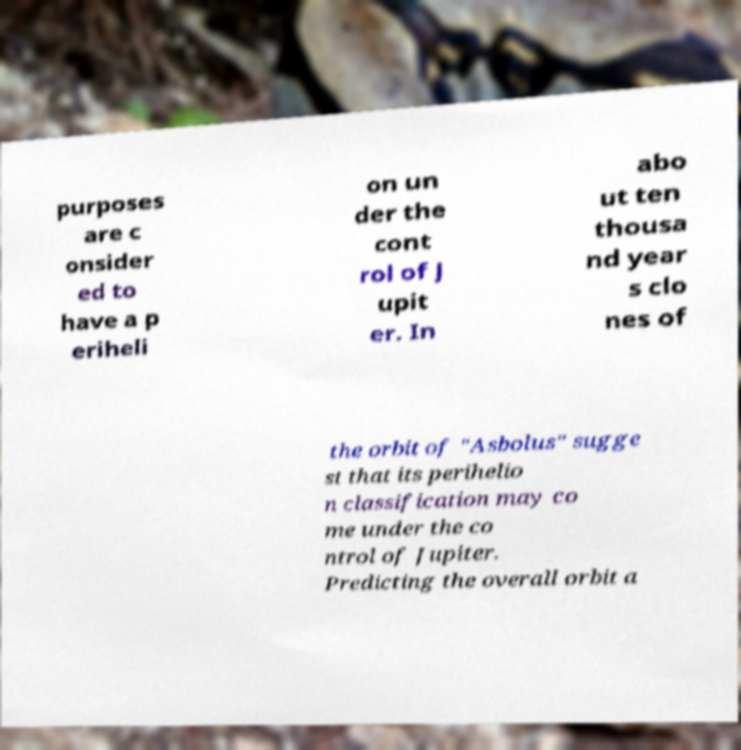Please read and relay the text visible in this image. What does it say? purposes are c onsider ed to have a p eriheli on un der the cont rol of J upit er. In abo ut ten thousa nd year s clo nes of the orbit of "Asbolus" sugge st that its perihelio n classification may co me under the co ntrol of Jupiter. Predicting the overall orbit a 